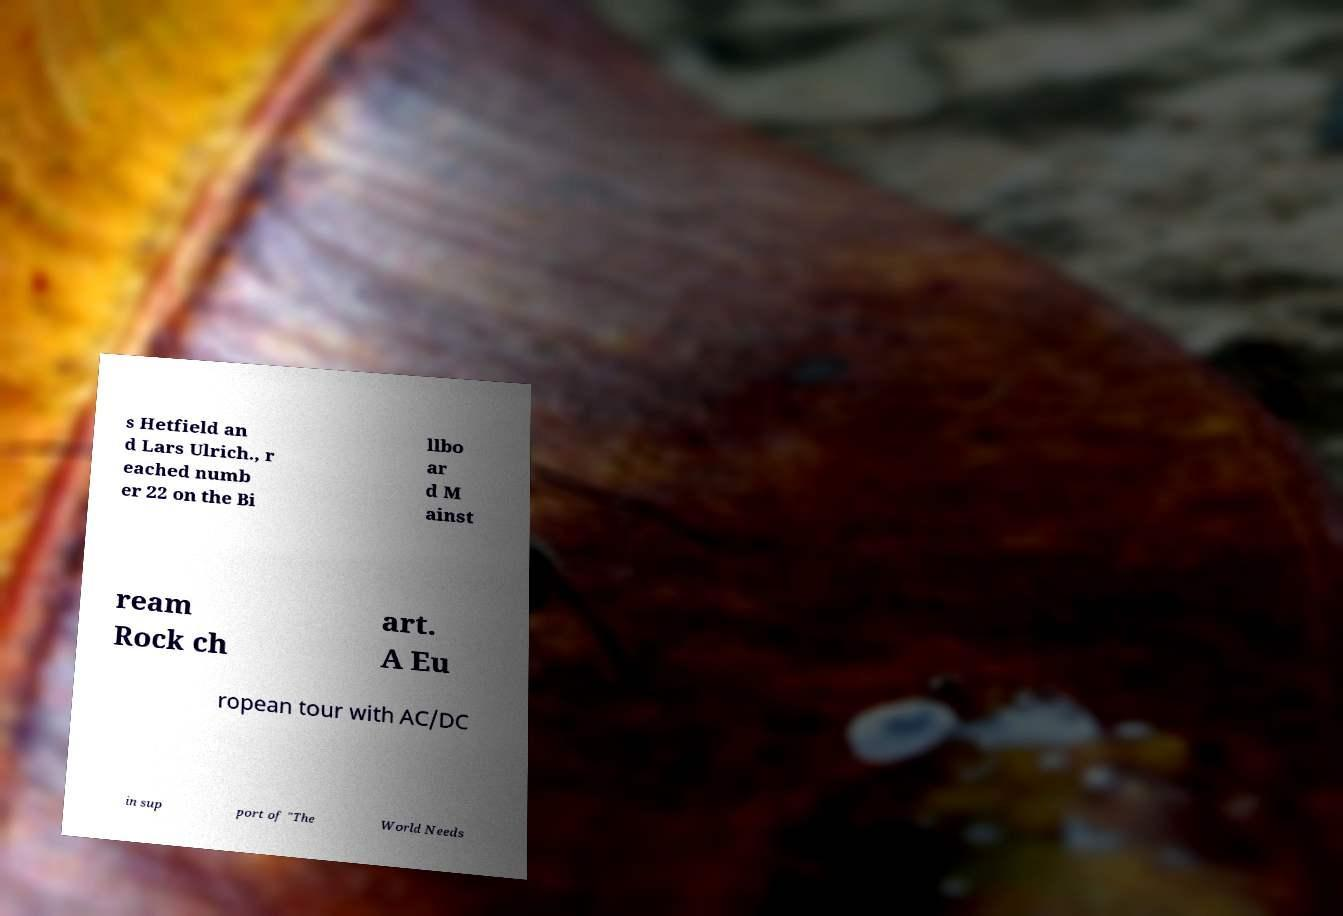What messages or text are displayed in this image? I need them in a readable, typed format. s Hetfield an d Lars Ulrich., r eached numb er 22 on the Bi llbo ar d M ainst ream Rock ch art. A Eu ropean tour with AC/DC in sup port of "The World Needs 